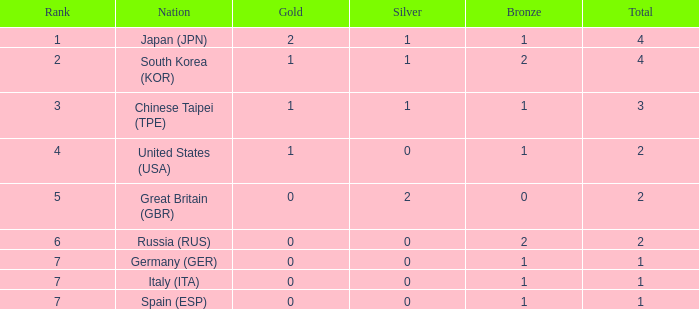What is the minimum amount of gold for a nation ranked 6th, having 2 bronzes? None. 